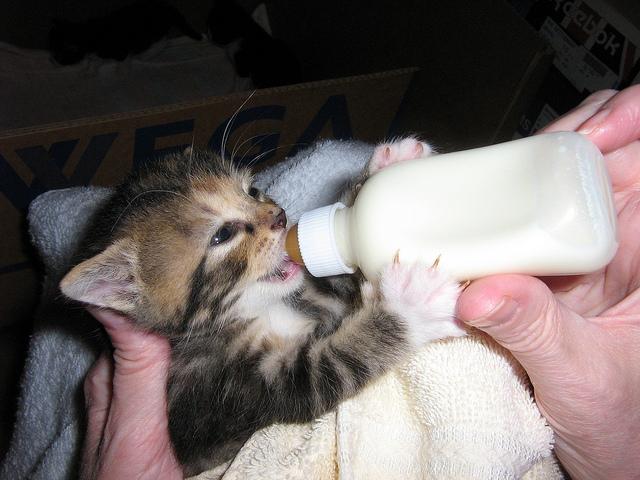Why is the person feeding the kitten this way?
Concise answer only. No mommy. Is that formula in the bottle?
Quick response, please. Yes. Is this a kitten or cat?
Answer briefly. Kitten. 